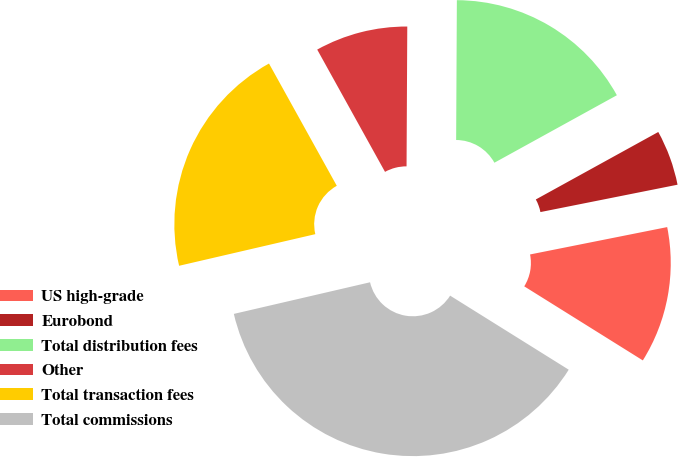Convert chart to OTSL. <chart><loc_0><loc_0><loc_500><loc_500><pie_chart><fcel>US high-grade<fcel>Eurobond<fcel>Total distribution fees<fcel>Other<fcel>Total transaction fees<fcel>Total commissions<nl><fcel>12.02%<fcel>4.88%<fcel>16.9%<fcel>8.14%<fcel>20.57%<fcel>37.48%<nl></chart> 